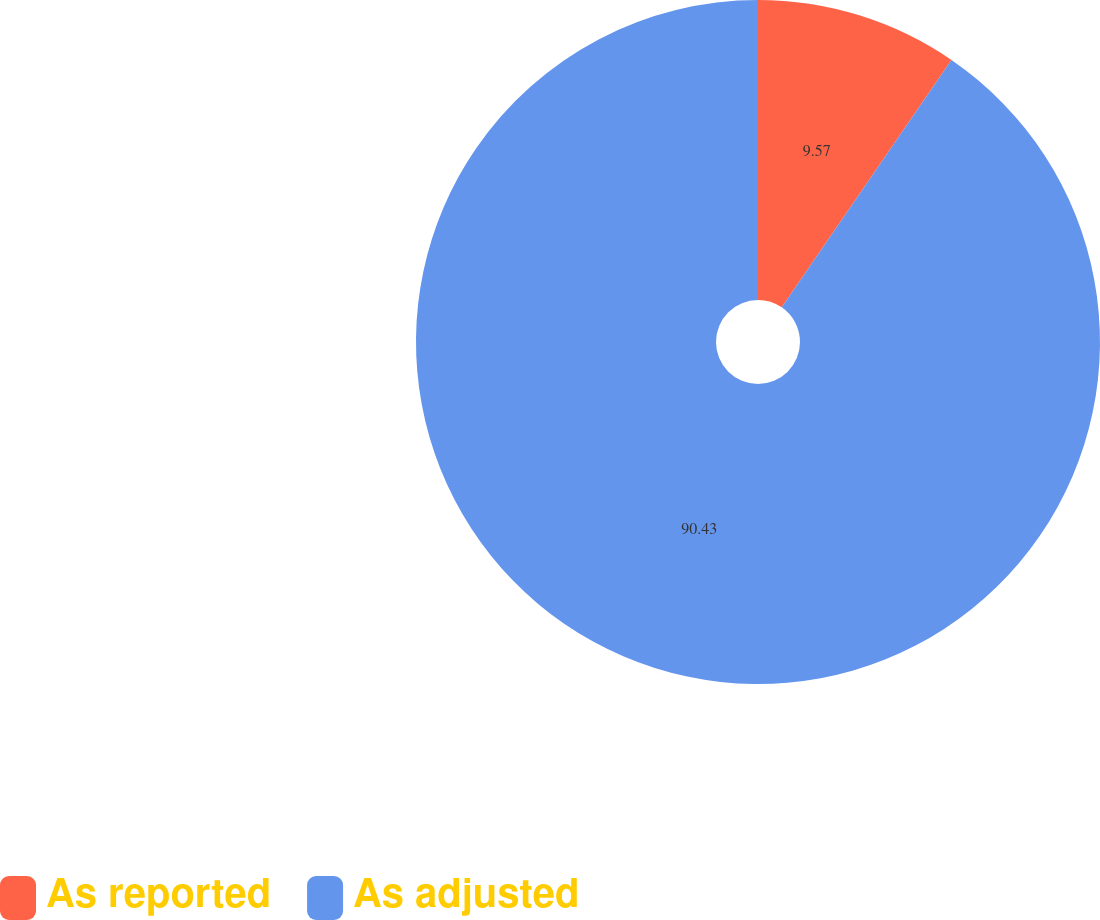Convert chart to OTSL. <chart><loc_0><loc_0><loc_500><loc_500><pie_chart><fcel>As reported<fcel>As adjusted<nl><fcel>9.57%<fcel>90.43%<nl></chart> 